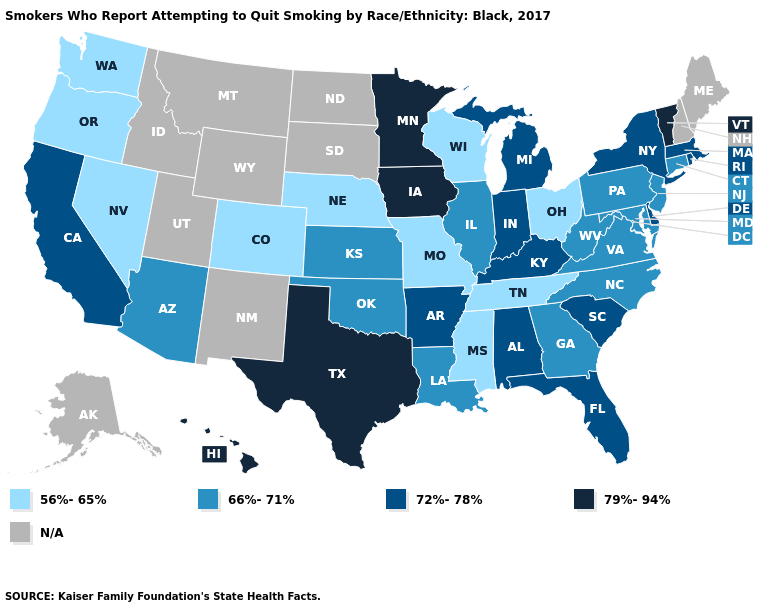Name the states that have a value in the range 72%-78%?
Give a very brief answer. Alabama, Arkansas, California, Delaware, Florida, Indiana, Kentucky, Massachusetts, Michigan, New York, Rhode Island, South Carolina. Does Virginia have the highest value in the USA?
Be succinct. No. What is the value of Arizona?
Be succinct. 66%-71%. Name the states that have a value in the range 56%-65%?
Write a very short answer. Colorado, Mississippi, Missouri, Nebraska, Nevada, Ohio, Oregon, Tennessee, Washington, Wisconsin. Name the states that have a value in the range N/A?
Give a very brief answer. Alaska, Idaho, Maine, Montana, New Hampshire, New Mexico, North Dakota, South Dakota, Utah, Wyoming. What is the value of Utah?
Give a very brief answer. N/A. What is the value of Wyoming?
Give a very brief answer. N/A. How many symbols are there in the legend?
Be succinct. 5. Which states have the lowest value in the USA?
Give a very brief answer. Colorado, Mississippi, Missouri, Nebraska, Nevada, Ohio, Oregon, Tennessee, Washington, Wisconsin. Name the states that have a value in the range N/A?
Give a very brief answer. Alaska, Idaho, Maine, Montana, New Hampshire, New Mexico, North Dakota, South Dakota, Utah, Wyoming. What is the value of Alabama?
Give a very brief answer. 72%-78%. What is the highest value in the Northeast ?
Answer briefly. 79%-94%. Which states have the lowest value in the Northeast?
Keep it brief. Connecticut, New Jersey, Pennsylvania. Among the states that border New Hampshire , does Massachusetts have the highest value?
Give a very brief answer. No. 